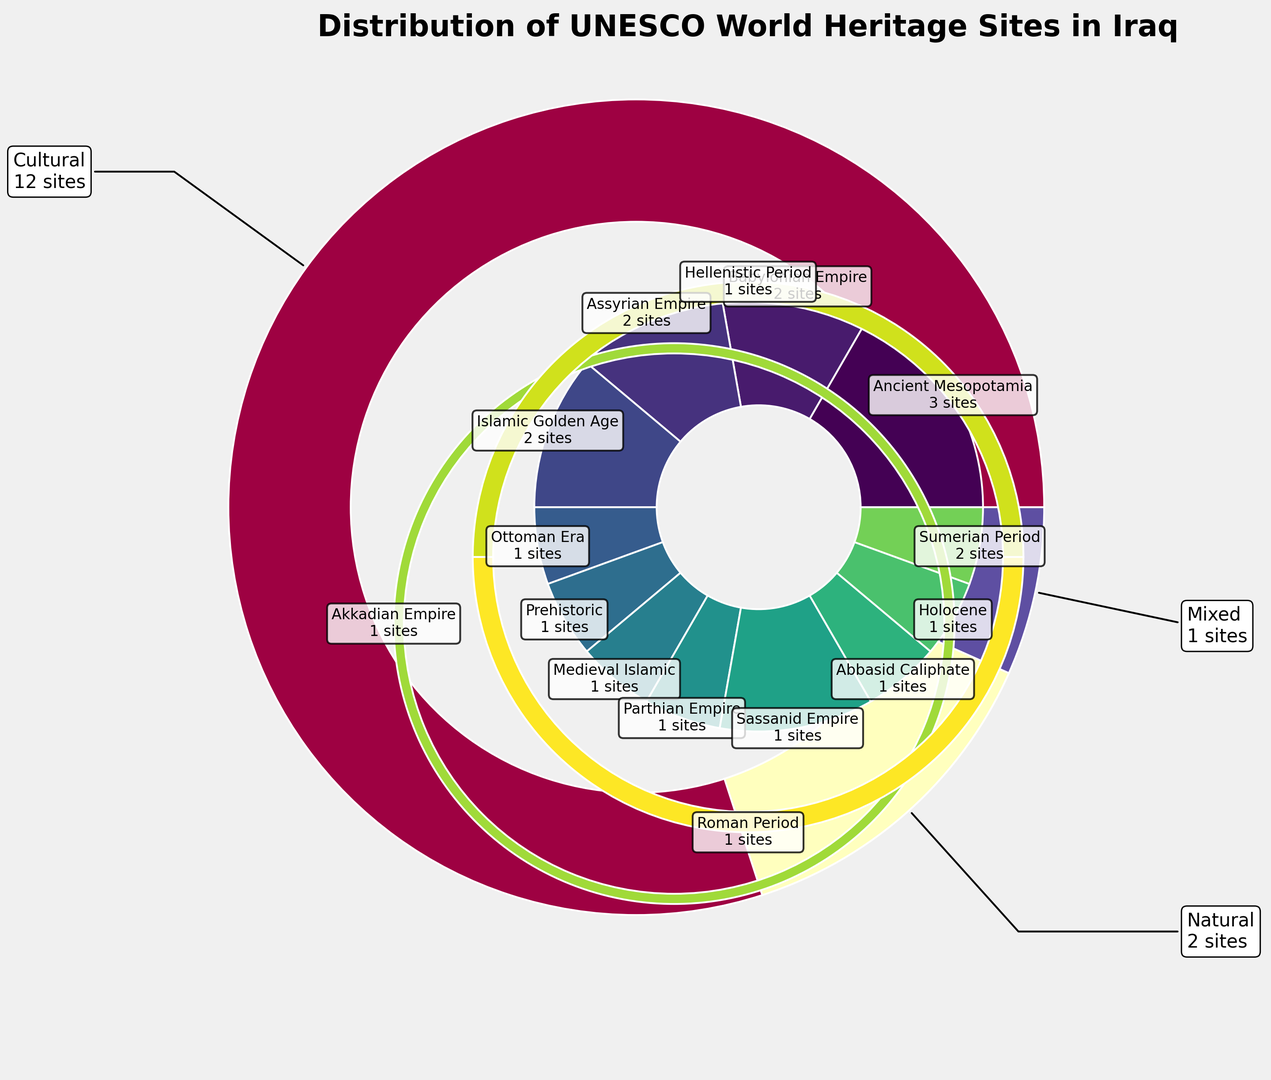What type has the highest number of UNESCO World Heritage Sites in Iraq? Look at the outer pie chart and identify which segment is the largest. The largest segment is labeled "Cultural" with 12 sites.
Answer: Cultural Which historical period has the most sites within the Cultural type? Among the cultural sites, the largest segment within the inner pie chart corresponds to "Ancient Mesopotamia" with 3 sites.
Answer: Ancient Mesopotamia Compare the number of Cultural and Natural sites. Which one has more, and by how many? Cultural sites have 12, and Natural sites have 2. The difference is 12 - 2 = 10 sites.
Answer: Cultural has 10 more sites How many total sites are listed under the Ancient Mesopotamia historical period? Ancient Mesopotamia is part of the Cultural type and has 3 sites.
Answer: 3 Which period under the Cultural type has exactly one site? The periods within the Cultural type with one site each are "Ottoman Era," "Parthian Empire," "Sassanid Empire," "Abbasid Caliphate," "Akkadian Empire," "Hellenistic Period," and "Roman Period."
Answer: Ottoman Era, Parthian Empire, Sassanid Empire, Abbasid Caliphate, Akkadian Empire, Hellenistic Period, Roman Period Compare the number of sites in the Islamic Golden Age and the Abbasid Caliphate. Which one has more? Islamic Golden Age has 2 sites; Abbasid Caliphate has 1 site. Therefore, Islamic Golden Age has more.
Answer: Islamic Golden Age What is the color associated with Natural sites in the outer pie chart? The outer segment for Natural sites can be identified by its color, which is visually distinguishable from the Cultural and Mixed segments. The color is cyan/light blue.
Answer: cyan/light blue How many types of sites has only one historical period listed? Look at each outer type and count how many inner periods each contains. The Mixed type has only one historical period listed.
Answer: 1 What is the total number of UNESCO World Heritage Sites represented in the chart? Add up the site counts for all historical periods: 3 + 2 + 2 + 2 + 1 + 1 + 1 + 1 + 1 + 1 + 1 + 2 + 1 + 1 + 1 = 20
Answer: 20 Which historical period has the highest representation after Ancient Mesopotamia? Examine the inner pie chart segments. After Ancient Mesopotamia, multiple periods including Babylonian Empire, Assyrian Empire, Islamic Golden Age, and Sumerian Period each have 2 sites.
Answer: Babylonian Empire, Assyrian Empire, Islamic Golden Age, Sumerian Period 